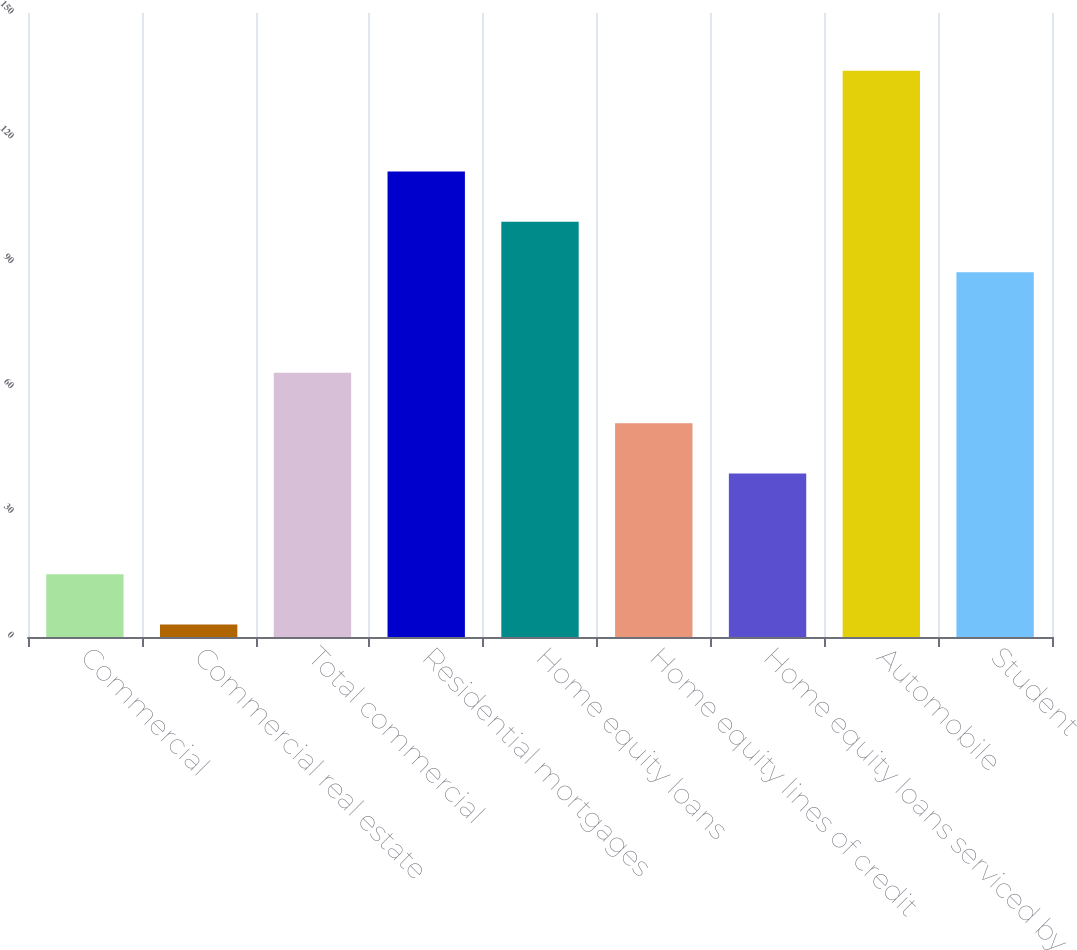Convert chart to OTSL. <chart><loc_0><loc_0><loc_500><loc_500><bar_chart><fcel>Commercial<fcel>Commercial real estate<fcel>Total commercial<fcel>Residential mortgages<fcel>Home equity loans<fcel>Home equity lines of credit<fcel>Home equity loans serviced by<fcel>Automobile<fcel>Student<nl><fcel>15.1<fcel>3<fcel>63.5<fcel>111.9<fcel>99.8<fcel>51.4<fcel>39.3<fcel>136.1<fcel>87.7<nl></chart> 